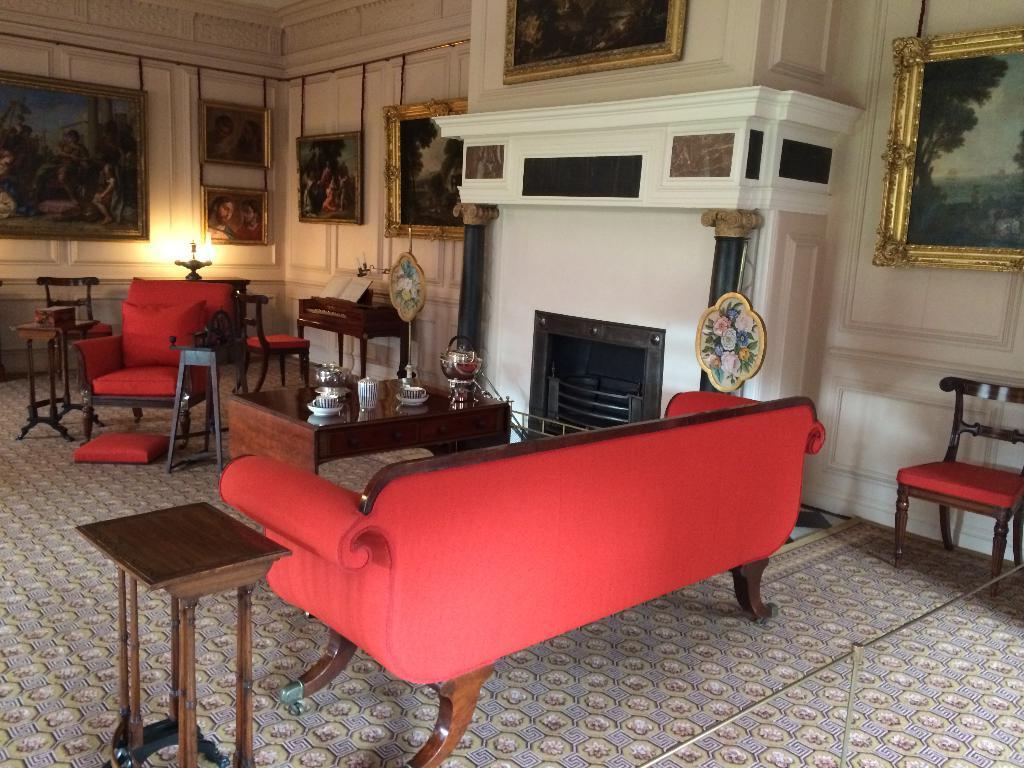Can you describe this image briefly? This is an inside view picture. We can see sofas and chairs in red colour and table and on the table we can see cups, saucers, and jars. This is a wall and on the wall we can see few photo frames. This is a floor carpet. 